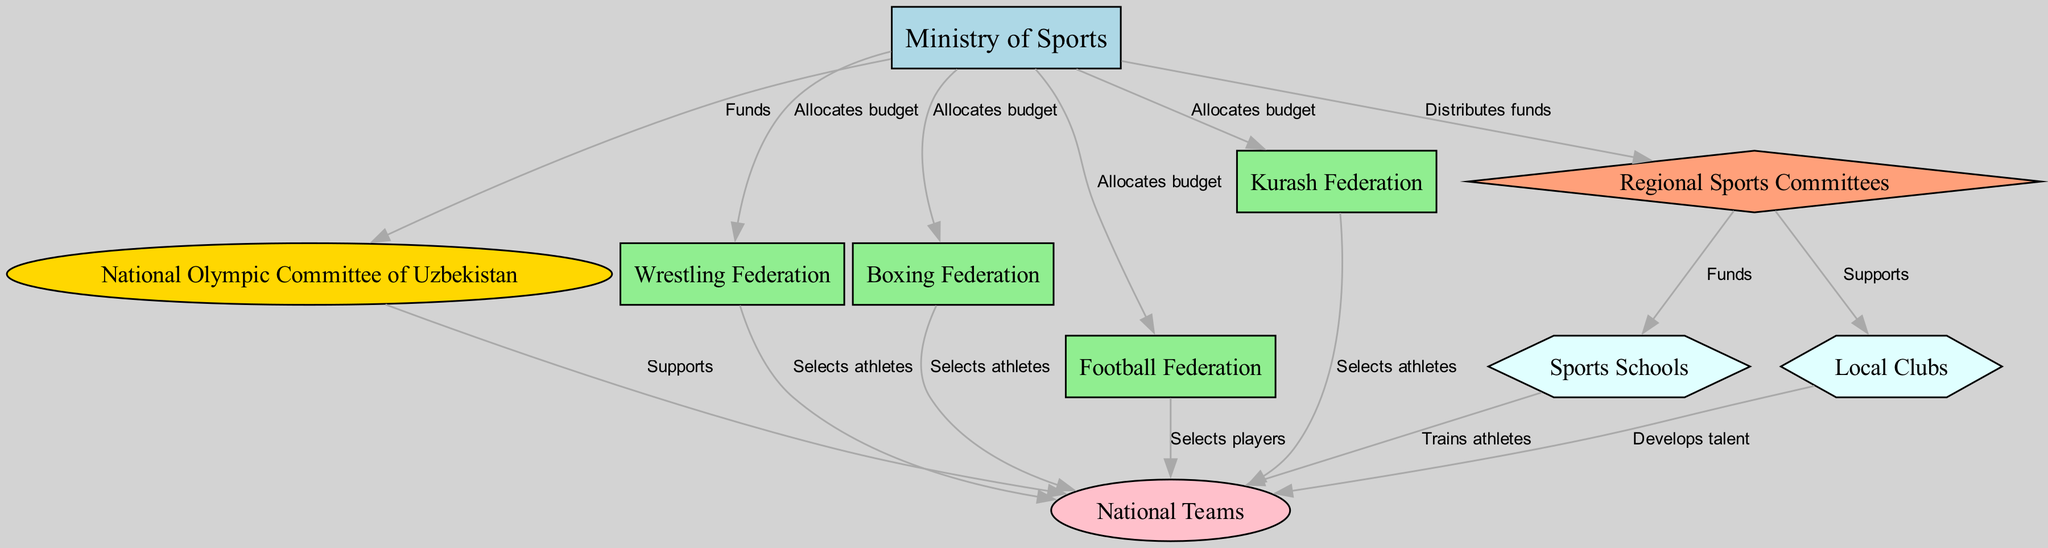What is the total number of nodes in the diagram? The nodes listed in the diagram are: Ministry of Sports, National Olympic Committee of Uzbekistan, Wrestling Federation, Boxing Federation, Football Federation, Kurash Federation, Regional Sports Committees, Sports Schools, National Teams, and Local Clubs. Counting these gives a total of 10 nodes.
Answer: 10 Which entity supports National Teams? The edges leading to National Teams come from the National Olympic Committee of Uzbekistan and several federations (Wrestling, Boxing, Football, Kurash). Therefore, the top-level support comes from the National Olympic Committee of Uzbekistan.
Answer: National Olympic Committee of Uzbekistan What do Regional Sports Committees fund? The edges indicate that Regional Sports Committees provide funds to Sports Schools and support Local Clubs. Thus, both entities receive funding from the Regional Sports Committees.
Answer: Sports Schools and Local Clubs What is the role of the Ministry of Sports? The edges indicate that the Ministry of Sports allocates budgets to various federations and distributes funds to Regional Sports Committees. This highlights its role in the overall funding flow within the sports hierarchy.
Answer: Allocates budget and distributes funds Which node directly selects athletes for the National Teams? The edges leading into the National Teams show selections coming from four specific federations: Wrestling, Boxing, Football, and Kurash. Therefore, all of these federations are capable of selecting athletes for the National Teams.
Answer: Wrestling Federation, Boxing Federation, Football Federation, Kurash Federation How is talent developed for the National Teams? The diagram shows edges from Local Clubs and Sports Schools to National Teams. This demonstrates that talent is developed from these two entities before being selected for the National Teams.
Answer: Local Clubs and Sports Schools Which federation receives funding from the Ministry of Sports but does not select athletes for National Teams? The Ministry of Sports allocates budgets to all federations included in the diagram, but among them, the Boxing Federation, Wrestling Federation, Football Federation, and Kurash Federation select athletes for National Teams. The remaining federations listed do not have edges leading to National Teams for athlete selection. Therefore, the National Olympic Committee of Uzbekistan stands out as a recipient of funds but does not directly select athletes.
Answer: National Olympic Committee of Uzbekistan How do Regional Sports Committees support Local Clubs? The diagram indicates that Regional Sports Committees support Local Clubs directly through a connecting edge, showing the relationship between the two entities.
Answer: Supports 